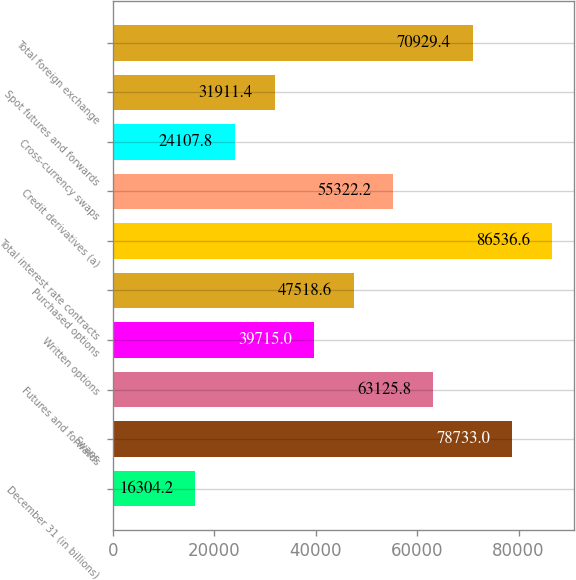Convert chart. <chart><loc_0><loc_0><loc_500><loc_500><bar_chart><fcel>December 31 (in billions)<fcel>Swaps<fcel>Futures and forwards<fcel>Written options<fcel>Purchased options<fcel>Total interest rate contracts<fcel>Credit derivatives (a)<fcel>Cross-currency swaps<fcel>Spot futures and forwards<fcel>Total foreign exchange<nl><fcel>16304.2<fcel>78733<fcel>63125.8<fcel>39715<fcel>47518.6<fcel>86536.6<fcel>55322.2<fcel>24107.8<fcel>31911.4<fcel>70929.4<nl></chart> 